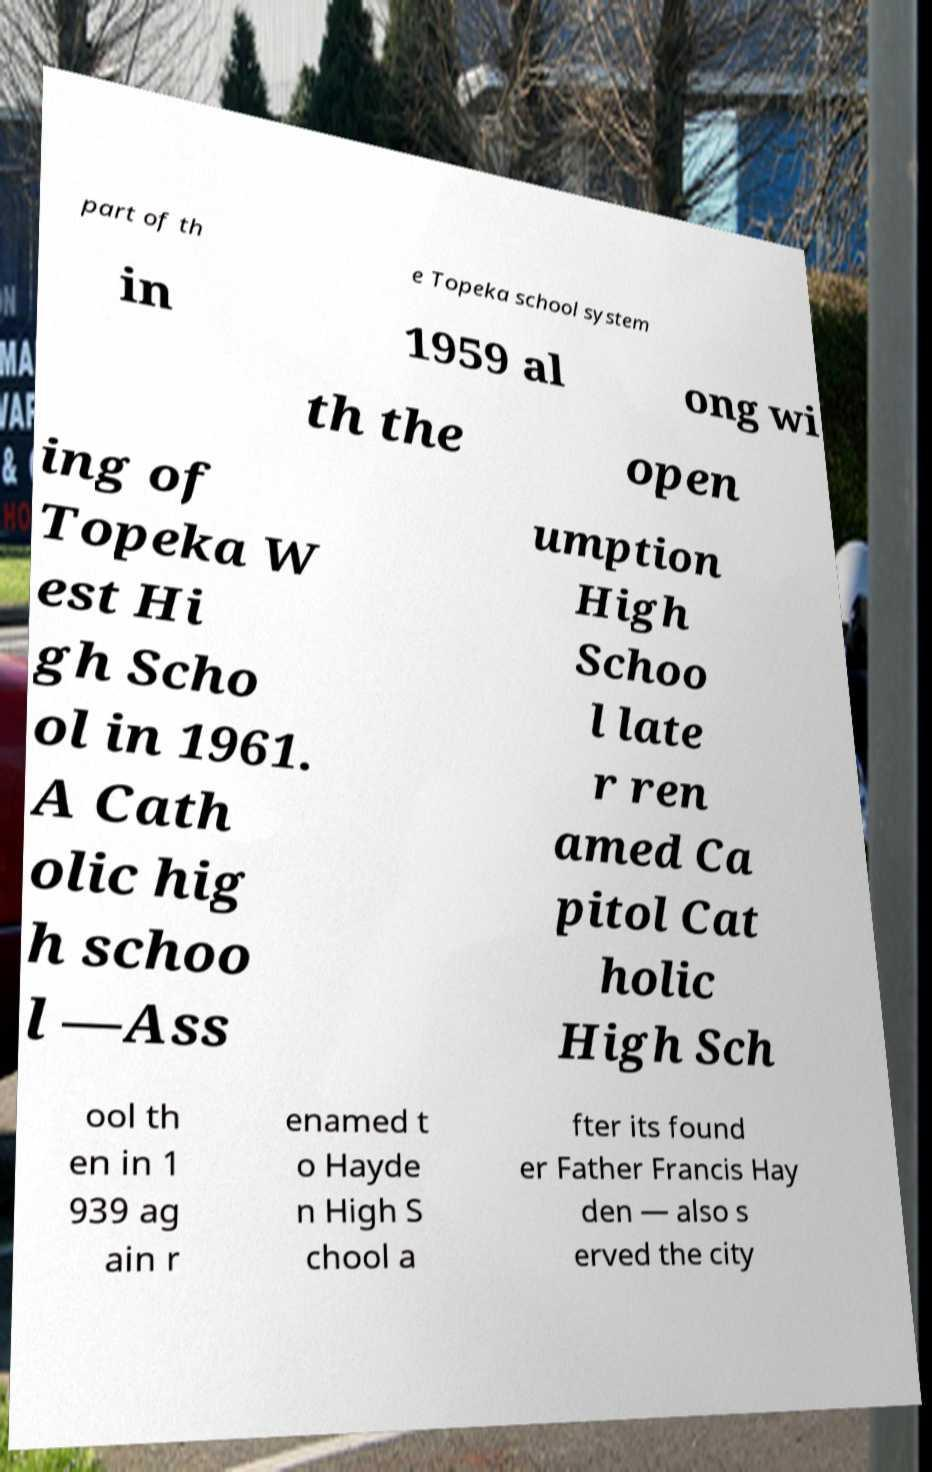Please identify and transcribe the text found in this image. part of th e Topeka school system in 1959 al ong wi th the open ing of Topeka W est Hi gh Scho ol in 1961. A Cath olic hig h schoo l —Ass umption High Schoo l late r ren amed Ca pitol Cat holic High Sch ool th en in 1 939 ag ain r enamed t o Hayde n High S chool a fter its found er Father Francis Hay den — also s erved the city 